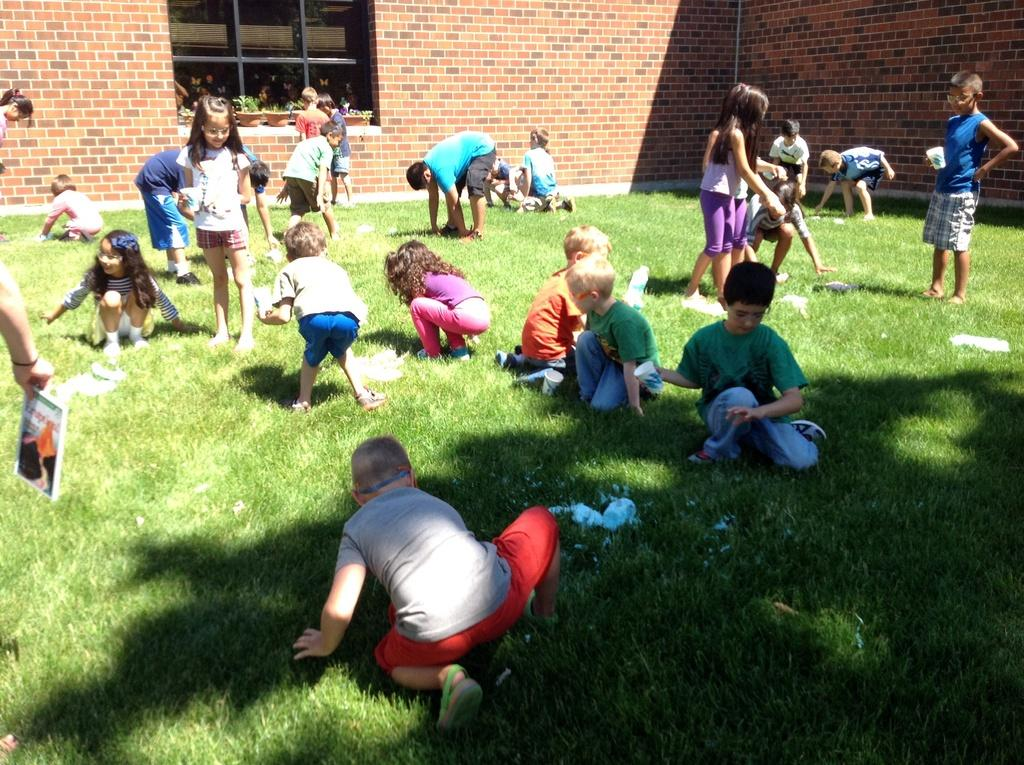How many kids are in the image? There are kids in the image, and one of them is holding a cup. What is the kid holding in the image? One kid is holding a cup. What is being held with a hand on the left side of the image? A book is held with a hand on the left side of the image. What type of natural environment is visible in the image? There is grass visible in the image. What can be seen in the background of the image? There is a wall, a window, and house plants in the background of the image. What type of horn can be seen on the cat in the image? There is no cat or horn present in the image. 